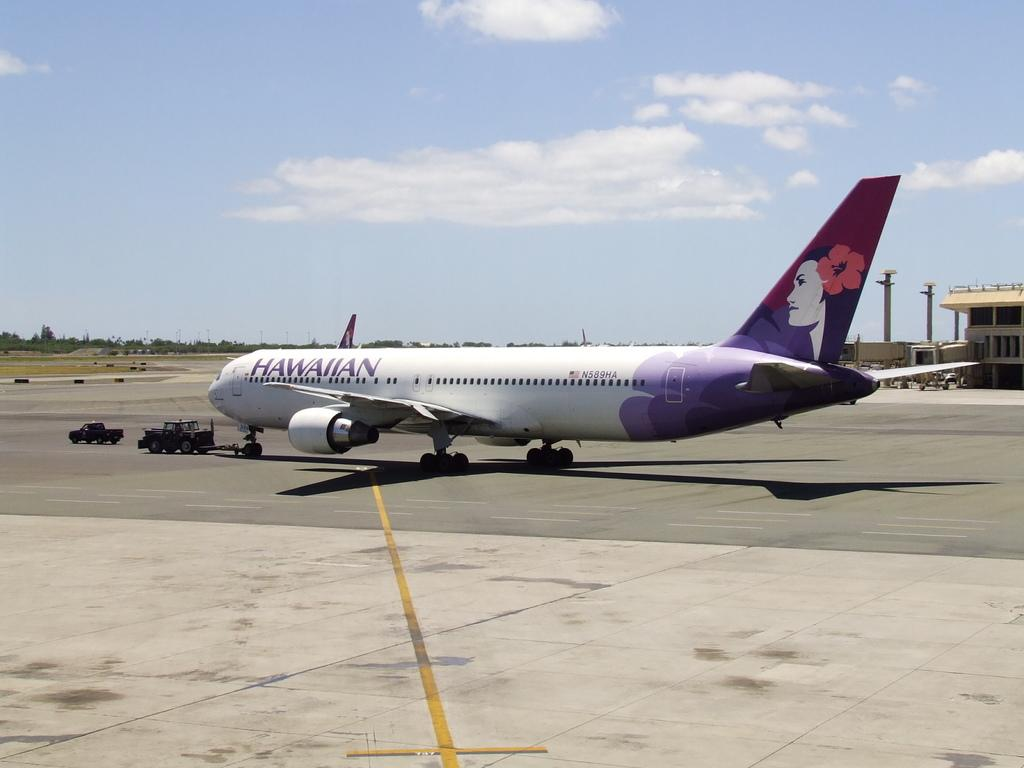<image>
Describe the image concisely. hawaiian airlines airplane with tow vehicle in front 